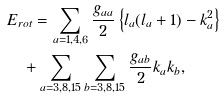Convert formula to latex. <formula><loc_0><loc_0><loc_500><loc_500>& E _ { r o t } = \sum _ { a = 1 , 4 , 6 } \frac { g _ { a a } } { 2 } \left \{ l _ { a } ( l _ { a } + 1 ) - k _ { a } ^ { 2 } \right \} \\ & \quad + \sum _ { a = 3 , 8 , 1 5 } \sum _ { b = 3 , 8 , 1 5 } \frac { g _ { a b } } { 2 } k _ { a } k _ { b } ,</formula> 